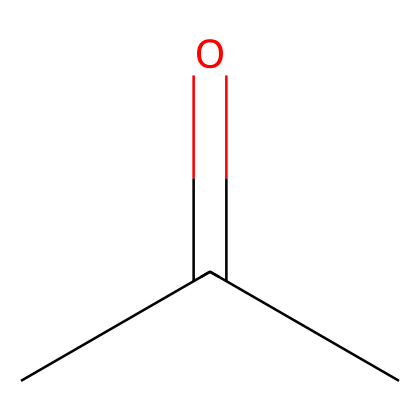What is the molecular formula of acetone? The SMILES representation CC(=O)C indicates that there are three carbon atoms (C), six hydrogen atoms (H), and one oxygen atom (O) in the molecule. Therefore, the molecular formula is C3H6O.
Answer: C3H6O How many carbon atoms are in acetone? By analyzing the SMILES representation CC(=O)C, we see three occurrences of the carbon atom symbol (C), indicating there are three carbon atoms present.
Answer: 3 What type of functional group is present in acetone? The presence of the carbonyl group (C=O), evidenced by the “(=O)” part of the SMILES, identifies acetone as a ketone, which is characterized by having a carbonyl group flanked by two carbon atoms.
Answer: ketone What is the total number of hydrogen atoms in acetone? In the molecular formula derived from the SMILES, which is C3H6O, there are six hydrogen atoms (H) present. This number can be confirmed by counting the hydrogen symbols associated with each carbon in the structure.
Answer: 6 How does the presence of the carbonyl group affect the polarity of acetone? The carbonyl group (C=O) is a polar functional group due to the difference in electronegativity between carbon and oxygen, making acetone a polar solvent. This polarity influences its ability to dissolve other polar and nonpolar substances.
Answer: polar What is the hybridization of the central carbon atom in acetone? The carbonyl carbon in acetone is sp2 hybridized because it forms three sigma bonds (one with oxygen and two with other carbons) and has a lone pair, resulting in a trigonal planar geometry surrounding that carbon atom.
Answer: sp2 